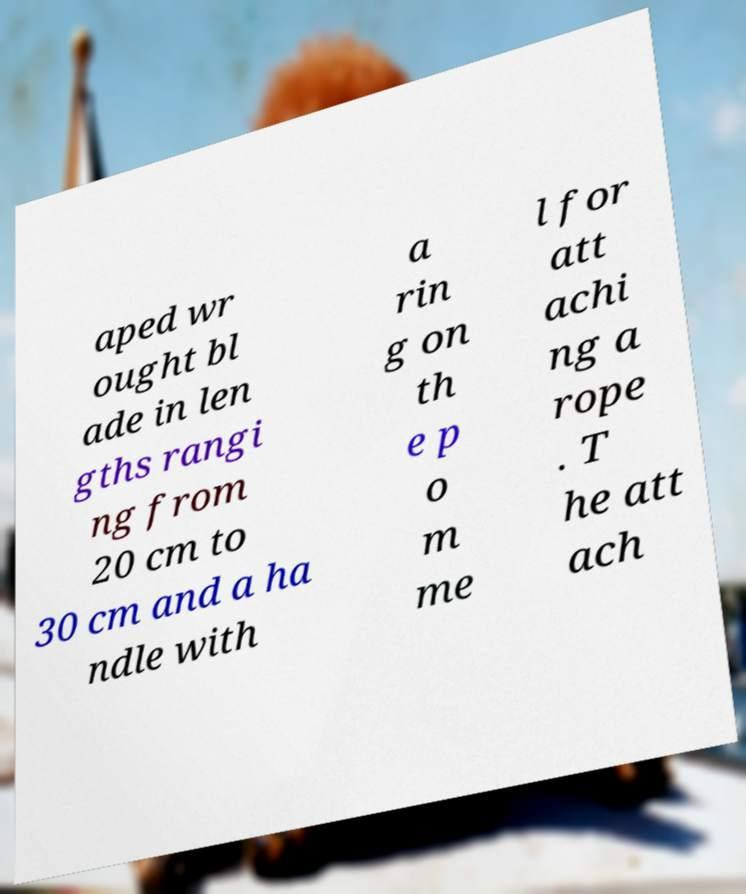Please identify and transcribe the text found in this image. aped wr ought bl ade in len gths rangi ng from 20 cm to 30 cm and a ha ndle with a rin g on th e p o m me l for att achi ng a rope . T he att ach 